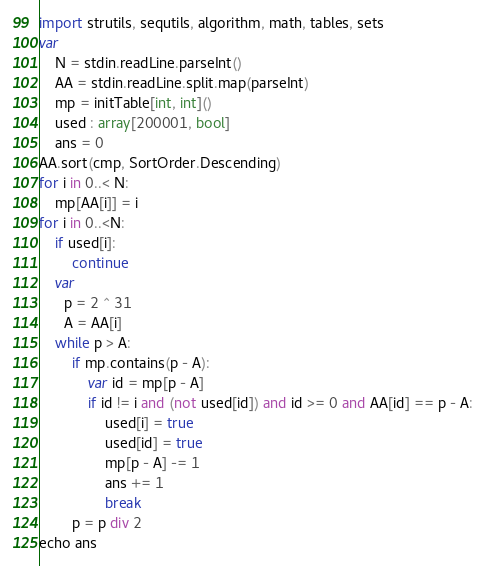<code> <loc_0><loc_0><loc_500><loc_500><_Nim_>import strutils, sequtils, algorithm, math, tables, sets
var
    N = stdin.readLine.parseInt()
    AA = stdin.readLine.split.map(parseInt)
    mp = initTable[int, int]()
    used : array[200001, bool]
    ans = 0
AA.sort(cmp, SortOrder.Descending)
for i in 0..< N:
    mp[AA[i]] = i
for i in 0..<N:
    if used[i]:
        continue
    var
      p = 2 ^ 31
      A = AA[i]
    while p > A:
        if mp.contains(p - A):
            var id = mp[p - A]
            if id != i and (not used[id]) and id >= 0 and AA[id] == p - A:
                used[i] = true
                used[id] = true
                mp[p - A] -= 1
                ans += 1
                break
        p = p div 2
echo ans
</code> 